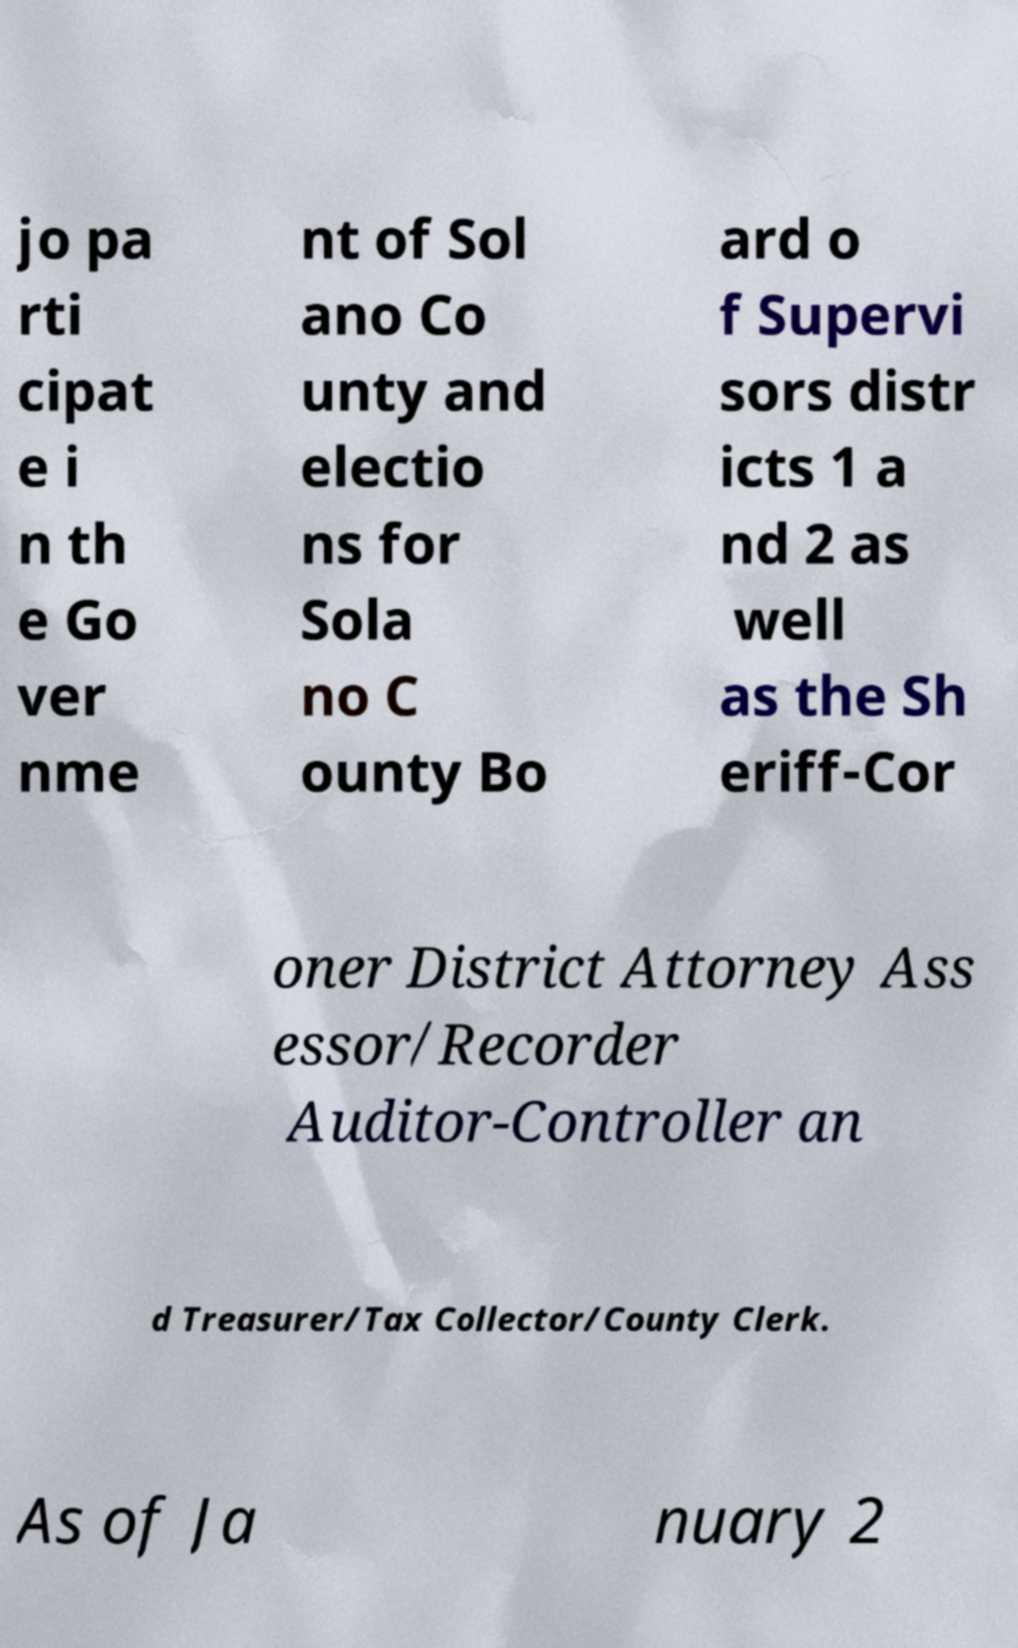Please identify and transcribe the text found in this image. jo pa rti cipat e i n th e Go ver nme nt of Sol ano Co unty and electio ns for Sola no C ounty Bo ard o f Supervi sors distr icts 1 a nd 2 as well as the Sh eriff-Cor oner District Attorney Ass essor/Recorder Auditor-Controller an d Treasurer/Tax Collector/County Clerk. As of Ja nuary 2 